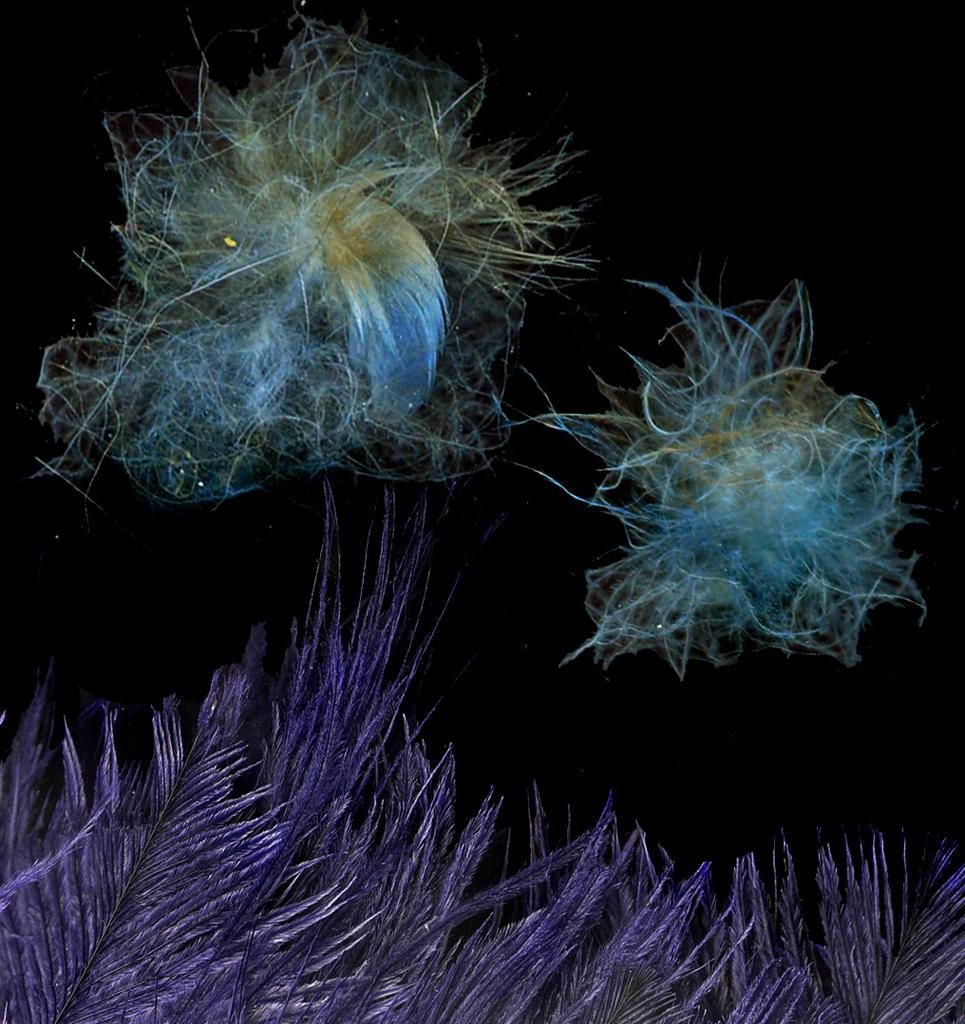What colors are present in the image? There are blue and purple-colored things in the image. What is the color of the background in the image? The background of the image appears to be black. How many children are playing with the spade in the bushes in the image? There are no children, spade, or bushes present in the image. 